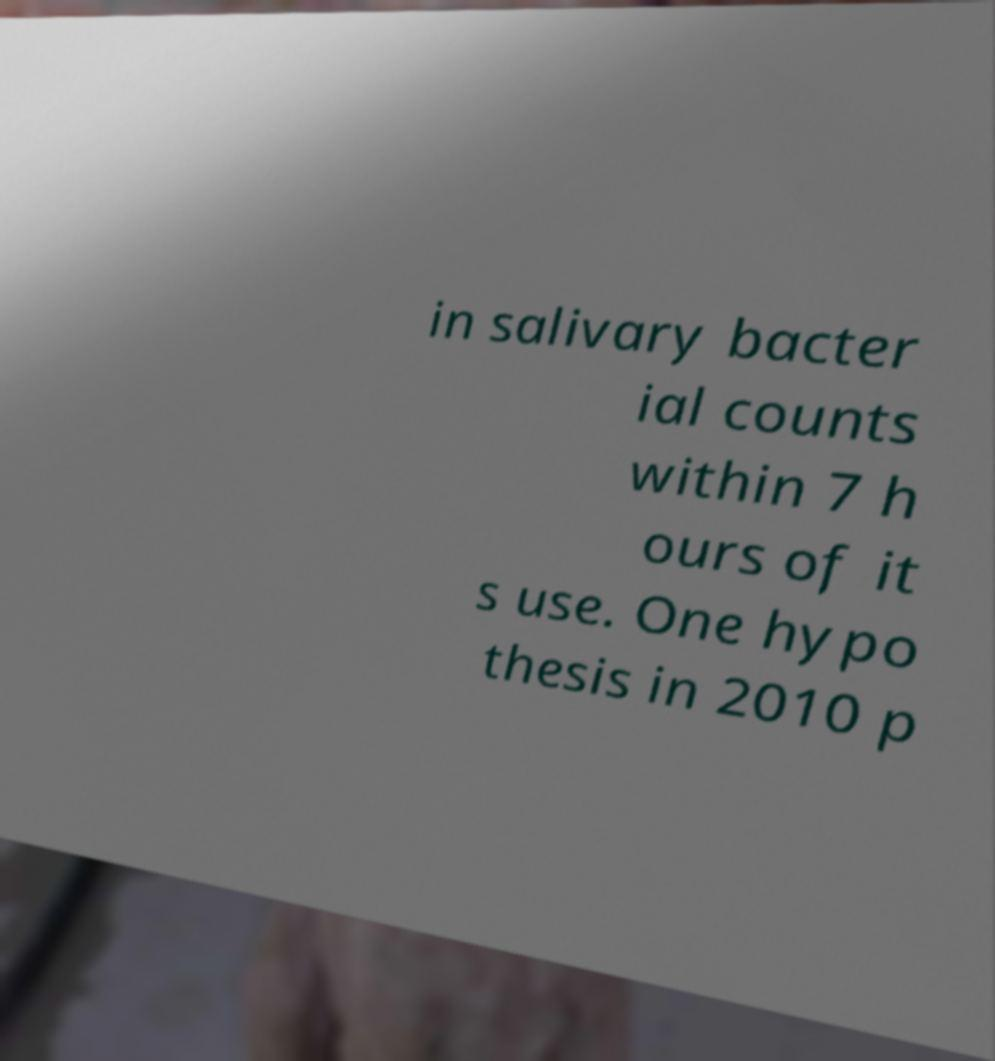Please identify and transcribe the text found in this image. in salivary bacter ial counts within 7 h ours of it s use. One hypo thesis in 2010 p 